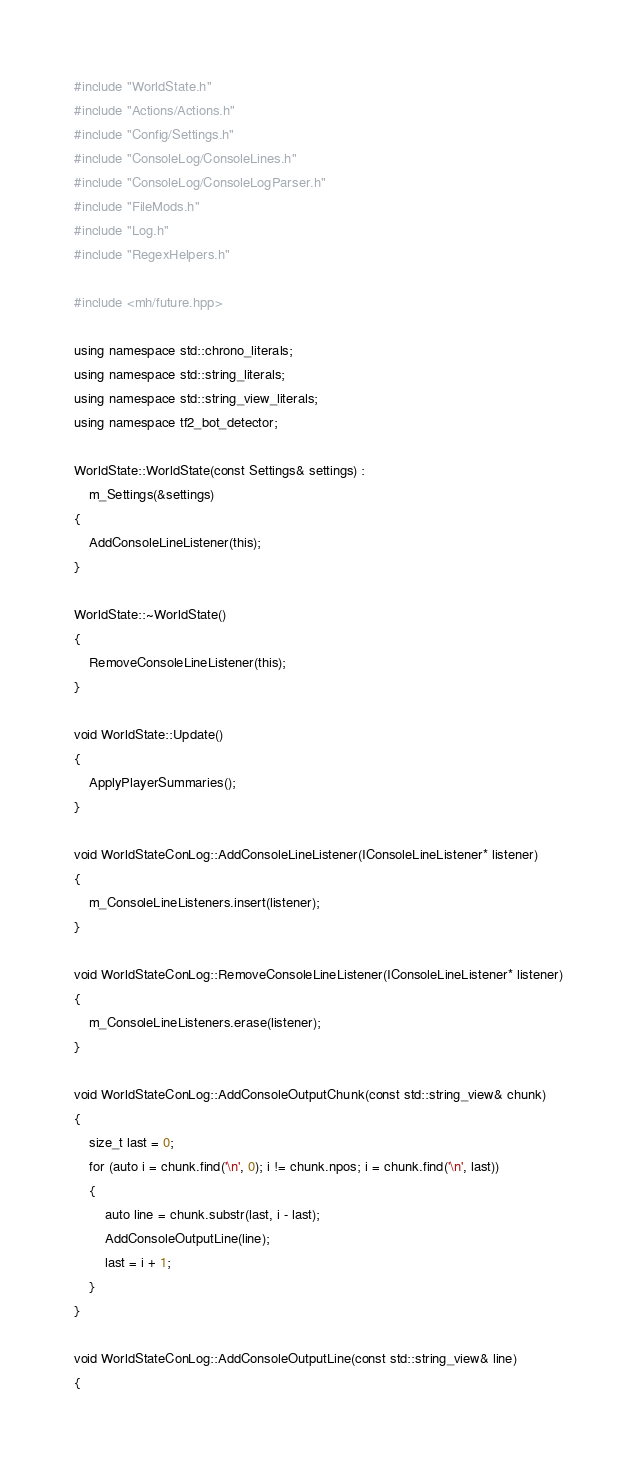Convert code to text. <code><loc_0><loc_0><loc_500><loc_500><_C++_>#include "WorldState.h"
#include "Actions/Actions.h"
#include "Config/Settings.h"
#include "ConsoleLog/ConsoleLines.h"
#include "ConsoleLog/ConsoleLogParser.h"
#include "FileMods.h"
#include "Log.h"
#include "RegexHelpers.h"

#include <mh/future.hpp>

using namespace std::chrono_literals;
using namespace std::string_literals;
using namespace std::string_view_literals;
using namespace tf2_bot_detector;

WorldState::WorldState(const Settings& settings) :
	m_Settings(&settings)
{
	AddConsoleLineListener(this);
}

WorldState::~WorldState()
{
	RemoveConsoleLineListener(this);
}

void WorldState::Update()
{
	ApplyPlayerSummaries();
}

void WorldStateConLog::AddConsoleLineListener(IConsoleLineListener* listener)
{
	m_ConsoleLineListeners.insert(listener);
}

void WorldStateConLog::RemoveConsoleLineListener(IConsoleLineListener* listener)
{
	m_ConsoleLineListeners.erase(listener);
}

void WorldStateConLog::AddConsoleOutputChunk(const std::string_view& chunk)
{
	size_t last = 0;
	for (auto i = chunk.find('\n', 0); i != chunk.npos; i = chunk.find('\n', last))
	{
		auto line = chunk.substr(last, i - last);
		AddConsoleOutputLine(line);
		last = i + 1;
	}
}

void WorldStateConLog::AddConsoleOutputLine(const std::string_view& line)
{</code> 